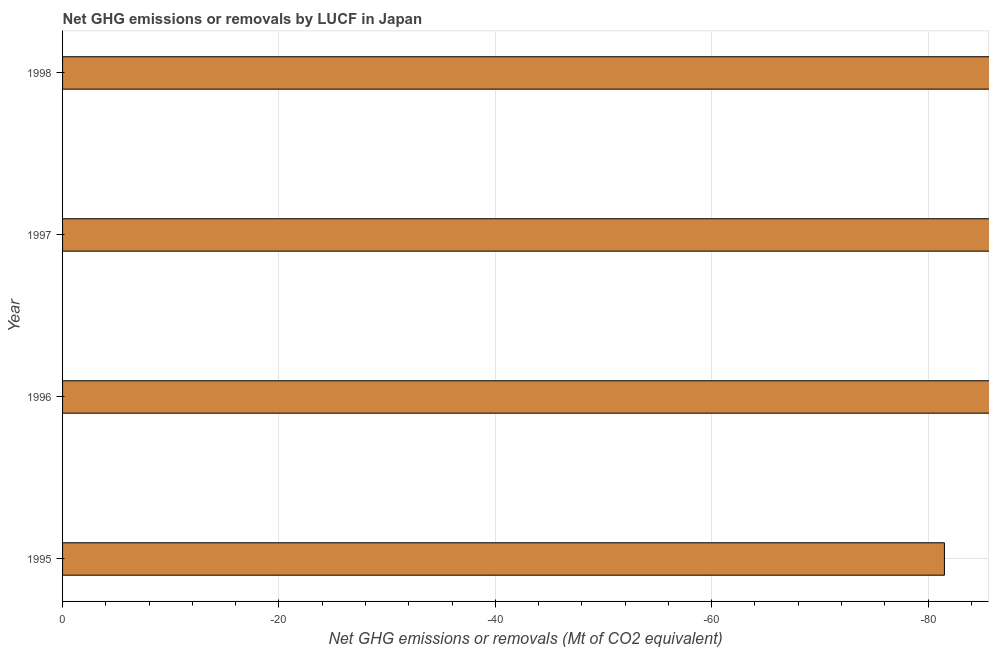Does the graph contain grids?
Keep it short and to the point. Yes. What is the title of the graph?
Ensure brevity in your answer.  Net GHG emissions or removals by LUCF in Japan. What is the label or title of the X-axis?
Offer a terse response. Net GHG emissions or removals (Mt of CO2 equivalent). What is the sum of the ghg net emissions or removals?
Your response must be concise. 0. Are all the bars in the graph horizontal?
Your answer should be compact. Yes. What is the difference between two consecutive major ticks on the X-axis?
Keep it short and to the point. 20. What is the Net GHG emissions or removals (Mt of CO2 equivalent) in 1997?
Ensure brevity in your answer.  0. What is the Net GHG emissions or removals (Mt of CO2 equivalent) of 1998?
Your response must be concise. 0. 